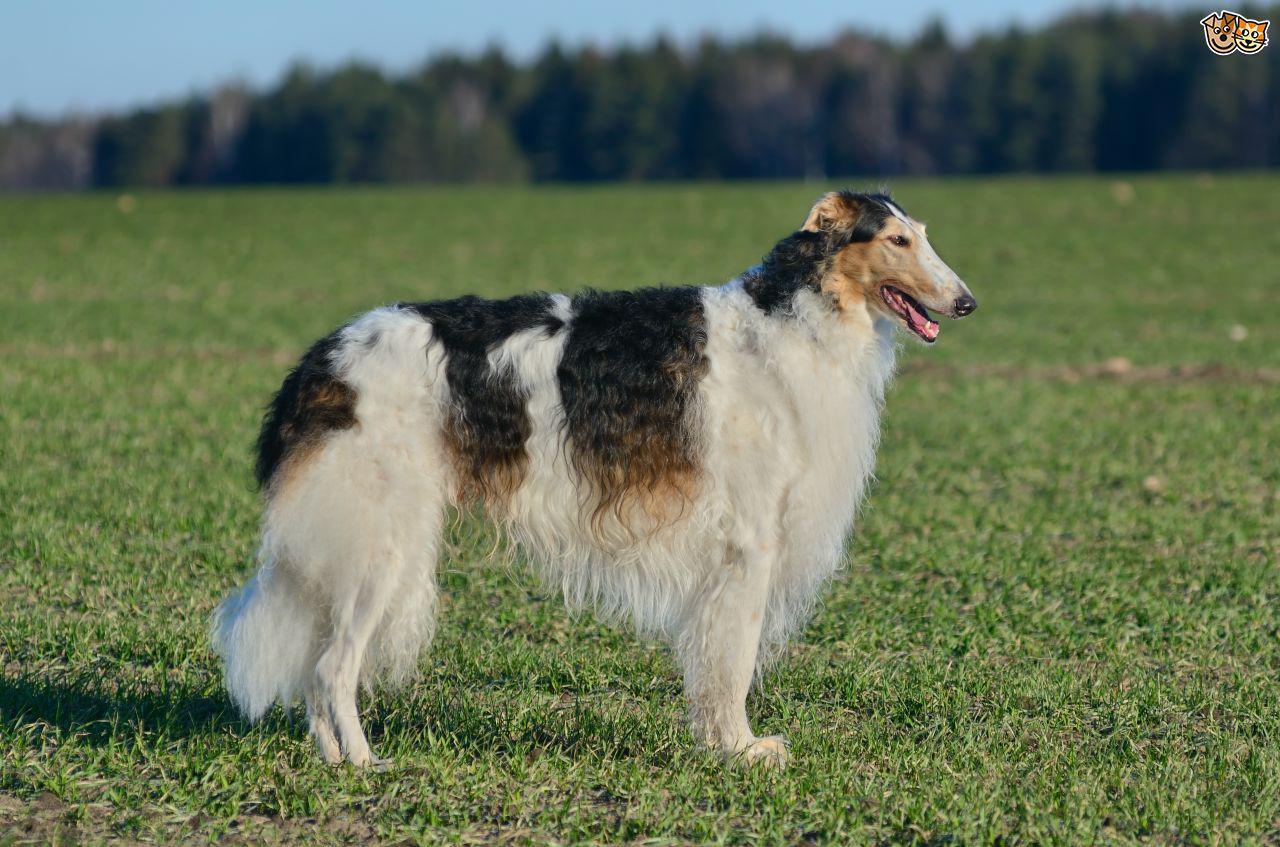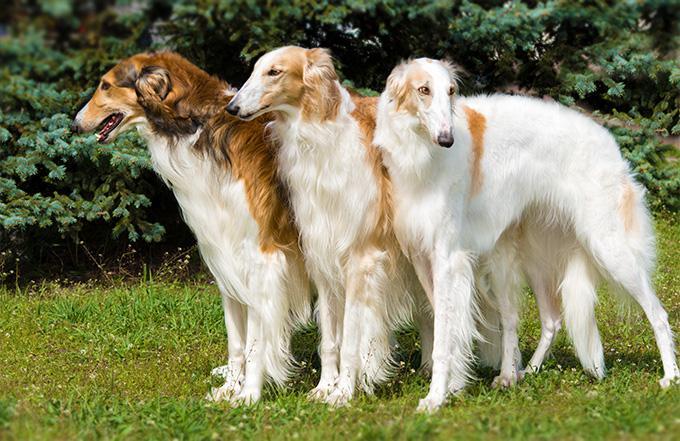The first image is the image on the left, the second image is the image on the right. Considering the images on both sides, is "The left image shows one reddish-orange and white dog in full profile, facing left." valid? Answer yes or no. No. 